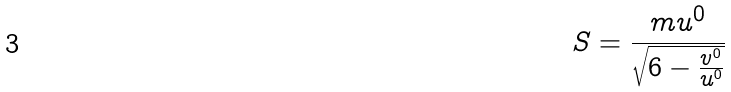<formula> <loc_0><loc_0><loc_500><loc_500>S = \frac { m u ^ { 0 } } { \sqrt { 6 - \frac { v ^ { 0 } } { u ^ { 0 } } } }</formula> 